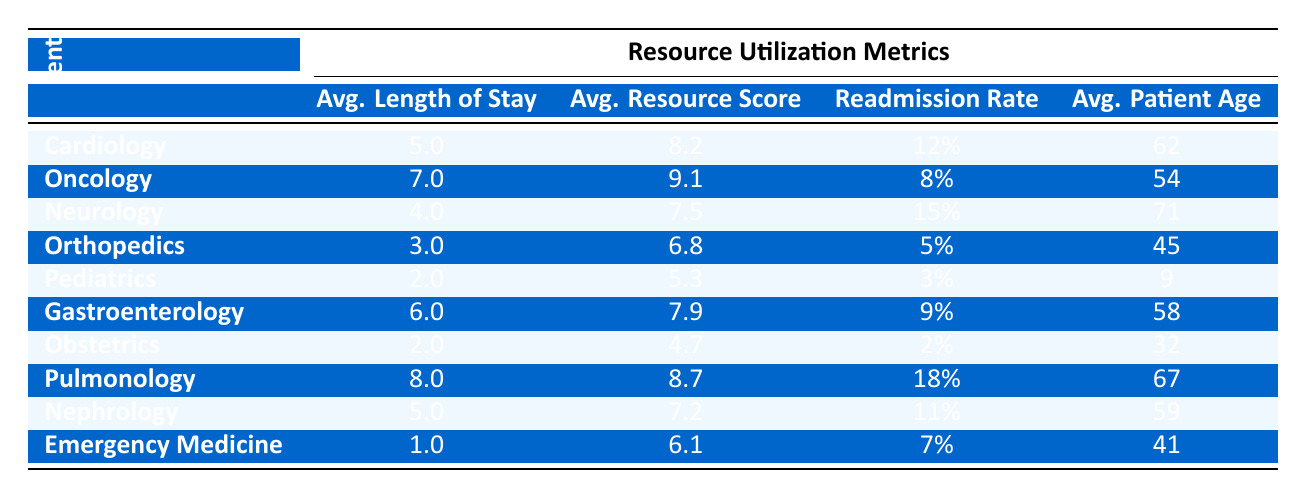What is the average length of stay in the Pediatrics department? In the table, the average length of stay for Pediatrics is listed as 2.0 days.
Answer: 2.0 Which department has the highest average resource utilization score? The highest average resource utilization score is found in the Oncology department with a score of 9.1.
Answer: 9.1 Is the readmission rate for Obstetrics higher than the readmission rate for Emergency Medicine? The readmission rate for Obstetrics is 2%, while for Emergency Medicine it is 7%. Since 2% is not higher than 7%, the statement is false.
Answer: No What is the average patient age in the Pulmonology department? The table shows that the average patient age in the Pulmonology department is 67 years old.
Answer: 67 Calculate the difference in average length of stay between the Cardiology and Orthopedics departments. The average length of stay in Cardiology is 5.0 days and in Orthopedics is 3.0 days. The difference is 5.0 - 3.0 = 2.0 days.
Answer: 2.0 Which department has the lowest patient age, and what is that age? The table shows that the Pediatrics department has the lowest average patient age of 9 years.
Answer: 9 Are the average resource utilization scores for Nephrology and Gastroenterology both below 8.0? In the table, the average resource utilization score for Nephrology is 7.2 and for Gastroenterology it is 7.9. Both values are below 8.0, making the statement true.
Answer: Yes What is the average readmission rate across all departments? To find the average readmission rate, sum the readmission rates (0.12 + 0.08 + 0.15 + 0.05 + 0.03 + 0.09 + 0.02 + 0.18 + 0.11 + 0.07 = 0.78) and divide by the number of departments (10): 0.78 / 10 = 0.078, or 7.8%.
Answer: 7.8% Which department shows the highest readmission rate, and what is that rate? By reviewing the table, the department with the highest readmission rate is Pulmonology at 18%.
Answer: 18% 